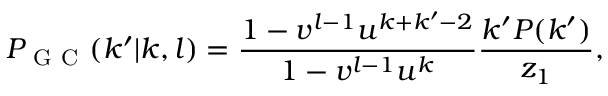Convert formula to latex. <formula><loc_0><loc_0><loc_500><loc_500>P _ { G C } ( k ^ { \prime } | k , l ) = \frac { 1 - v ^ { l - 1 } u ^ { k + k ^ { \prime } - 2 } } { 1 - v ^ { l - 1 } u ^ { k } } \frac { k ^ { \prime } P ( k ^ { \prime } ) } { z _ { 1 } } ,</formula> 